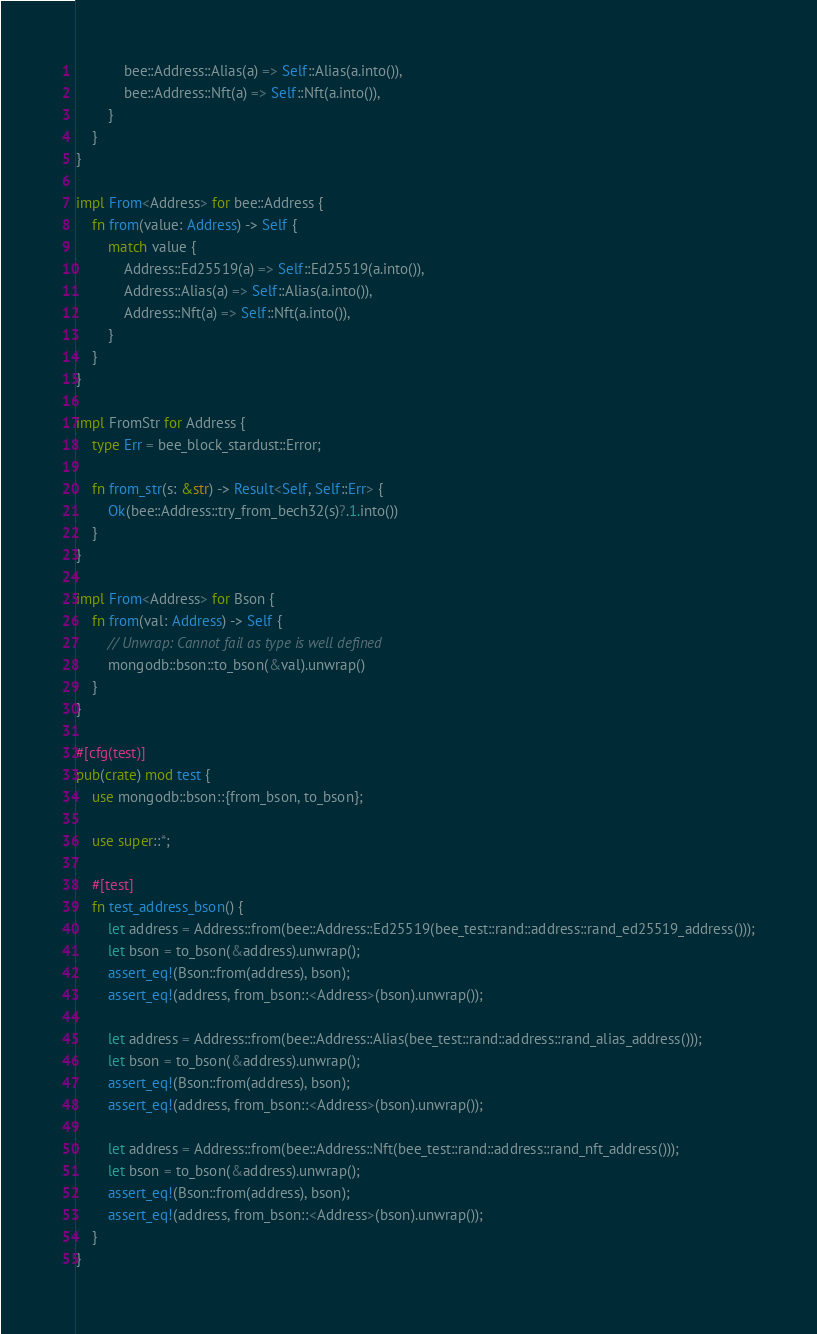<code> <loc_0><loc_0><loc_500><loc_500><_Rust_>            bee::Address::Alias(a) => Self::Alias(a.into()),
            bee::Address::Nft(a) => Self::Nft(a.into()),
        }
    }
}

impl From<Address> for bee::Address {
    fn from(value: Address) -> Self {
        match value {
            Address::Ed25519(a) => Self::Ed25519(a.into()),
            Address::Alias(a) => Self::Alias(a.into()),
            Address::Nft(a) => Self::Nft(a.into()),
        }
    }
}

impl FromStr for Address {
    type Err = bee_block_stardust::Error;

    fn from_str(s: &str) -> Result<Self, Self::Err> {
        Ok(bee::Address::try_from_bech32(s)?.1.into())
    }
}

impl From<Address> for Bson {
    fn from(val: Address) -> Self {
        // Unwrap: Cannot fail as type is well defined
        mongodb::bson::to_bson(&val).unwrap()
    }
}

#[cfg(test)]
pub(crate) mod test {
    use mongodb::bson::{from_bson, to_bson};

    use super::*;

    #[test]
    fn test_address_bson() {
        let address = Address::from(bee::Address::Ed25519(bee_test::rand::address::rand_ed25519_address()));
        let bson = to_bson(&address).unwrap();
        assert_eq!(Bson::from(address), bson);
        assert_eq!(address, from_bson::<Address>(bson).unwrap());

        let address = Address::from(bee::Address::Alias(bee_test::rand::address::rand_alias_address()));
        let bson = to_bson(&address).unwrap();
        assert_eq!(Bson::from(address), bson);
        assert_eq!(address, from_bson::<Address>(bson).unwrap());

        let address = Address::from(bee::Address::Nft(bee_test::rand::address::rand_nft_address()));
        let bson = to_bson(&address).unwrap();
        assert_eq!(Bson::from(address), bson);
        assert_eq!(address, from_bson::<Address>(bson).unwrap());
    }
}
</code> 